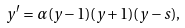Convert formula to latex. <formula><loc_0><loc_0><loc_500><loc_500>y ^ { \prime } = \alpha ( y - 1 ) ( y + 1 ) ( y - s ) ,</formula> 